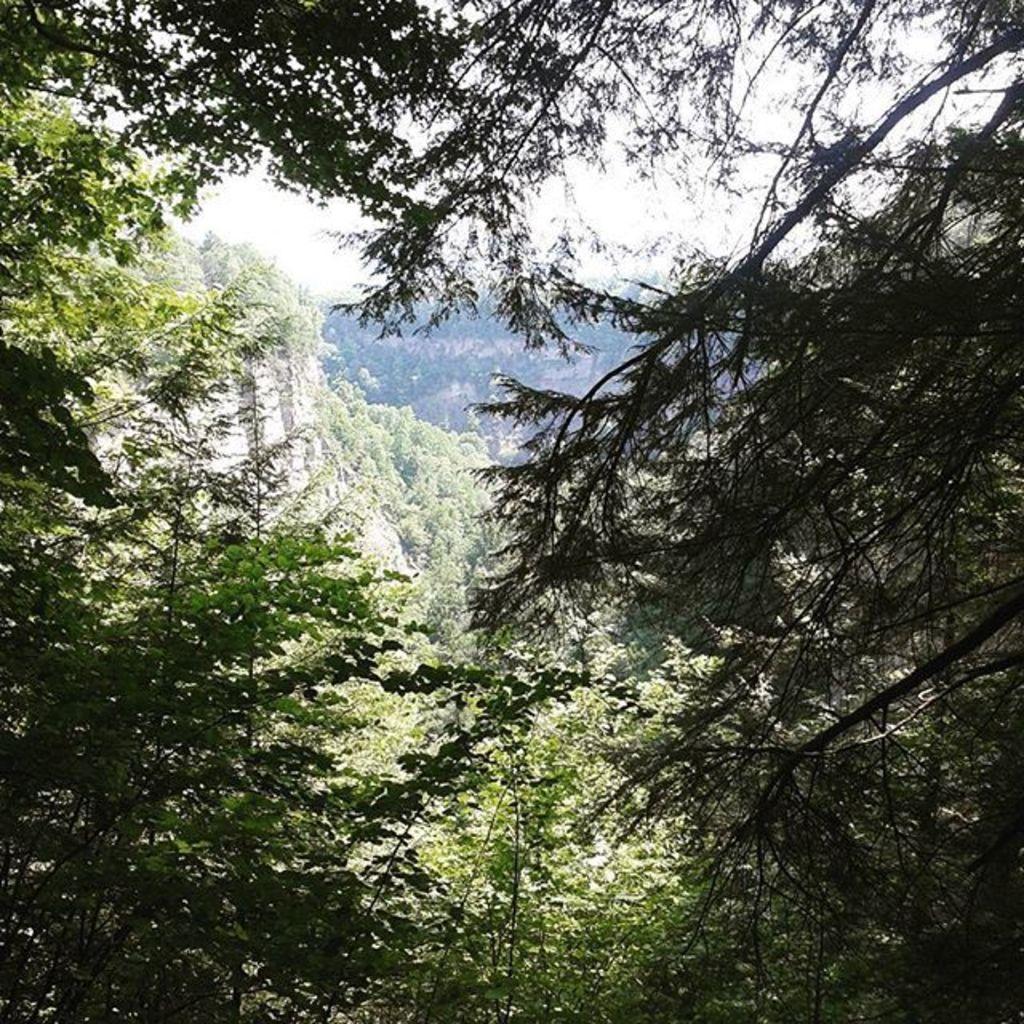How would you summarize this image in a sentence or two? This picture is taken from outside of the city. In this image, on the right side and left side, we can see some trees and plants. In the background, we can see some rocks, trees, plants. At the top, we can see a sky, at the bottom, we can see a plant and trees. 